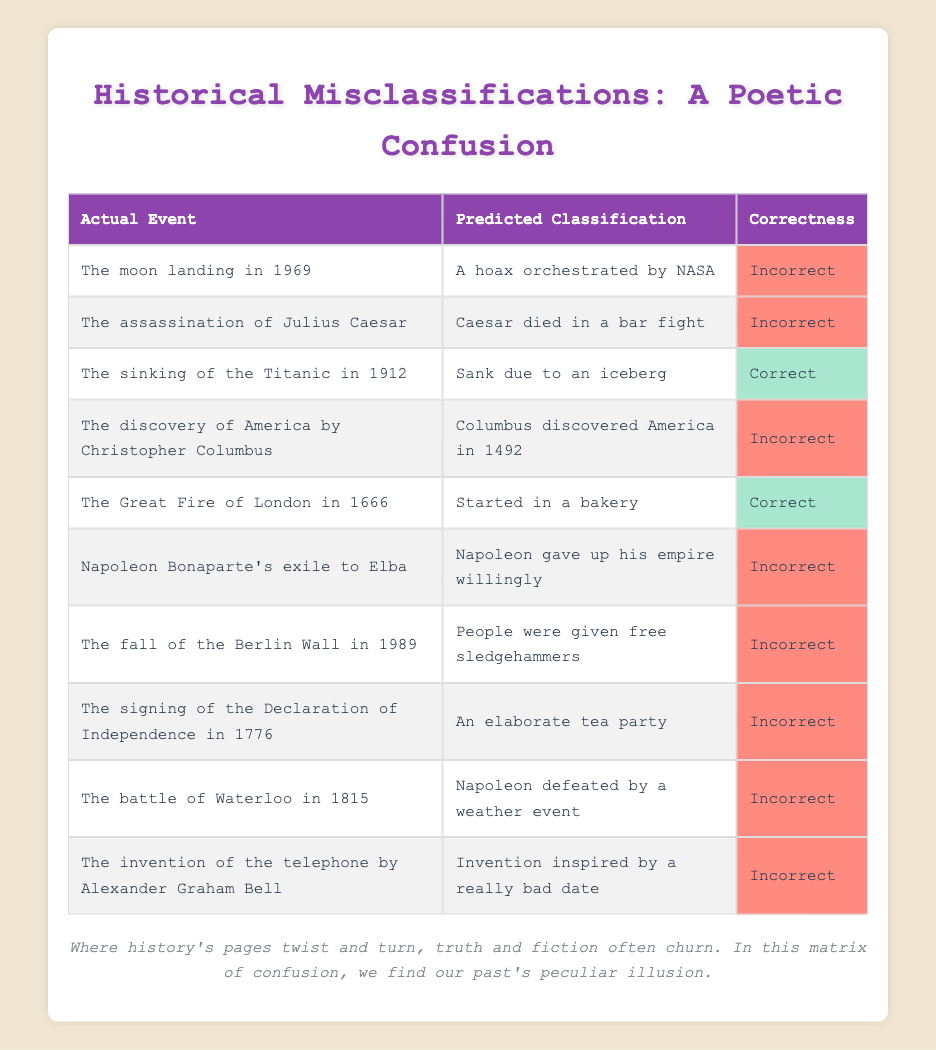What actual event was predicted to be a hoax? The table shows that "The moon landing in 1969" was predicted to be "A hoax orchestrated by NASA."
Answer: The moon landing in 1969 Which historical event was correctly classified as starting in a bakery? According to the table, "The Great Fire of London in 1666" was accurately predicted to have started in a bakery.
Answer: The Great Fire of London in 1666 How many events were incorrectly classified? By examining the table, we see there are 9 instances tagged as "Incorrect" out of the 10 listed events.
Answer: 9 Is it true that Napoleon Bonaparte willingly gave up his empire when exiled to Elba? The table indicates that the statement "Napoleon gave up his empire willingly" is marked as incorrect.
Answer: No What percentage of the total events listed were classified correctly? There are 2 events classified as "Correct" out of a total of 10 events, so (2/10) * 100 = 20%.
Answer: 20% Which two events were correctly classified? From the table, we find that "The sinking of the Titanic in 1912" and "The Great Fire of London in 1666" are the events marked as "Correct."
Answer: The sinking of the Titanic in 1912 and The Great Fire of London in 1666 What can be inferred about the predicted classification of Columbus discovering America in 1492? The table shows that it was incorrectly classified, suggesting a misunderstanding or oversimplification of the event.
Answer: It was incorrectly classified What historical event had a predicted classification related to a weather event? The table indicates that "The battle of Waterloo in 1815" was incorrectly classified as "Napoleon defeated by a weather event."
Answer: The battle of Waterloo in 1815 How many events were inaccurately reported as involving people? Analyzing the table, we see only one event, "The fall of the Berlin Wall in 1989," involved a prediction about people (related to sledgehammers), which was incorrect.
Answer: 1 